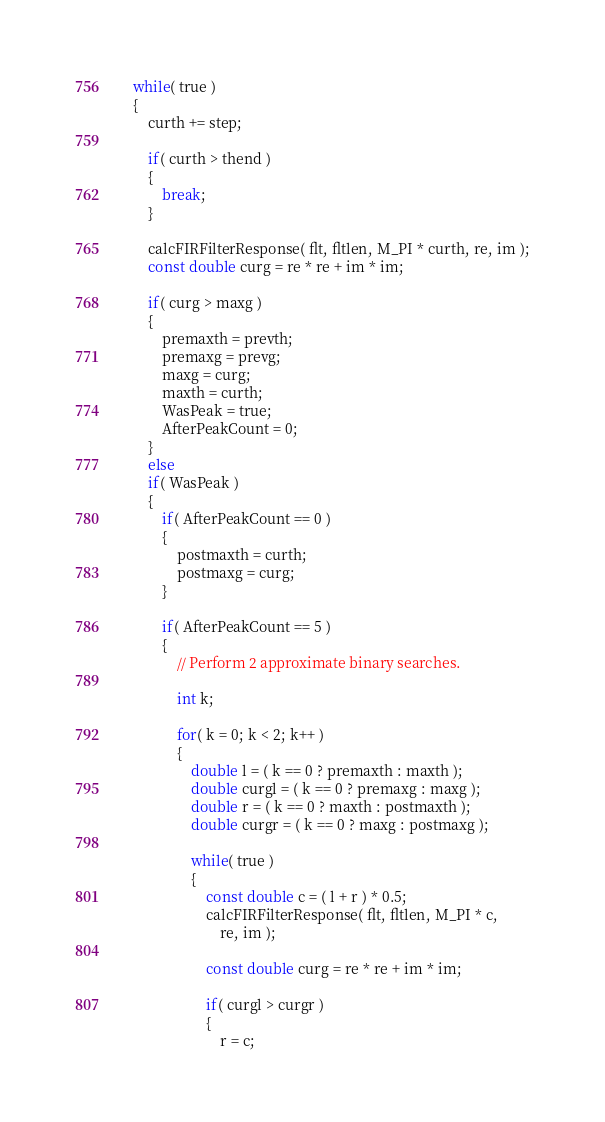<code> <loc_0><loc_0><loc_500><loc_500><_C_>
	while( true )
	{
		curth += step;

		if( curth > thend )
		{
			break;
		}

		calcFIRFilterResponse( flt, fltlen, M_PI * curth, re, im );
		const double curg = re * re + im * im;

		if( curg > maxg )
		{
			premaxth = prevth;
			premaxg = prevg;
			maxg = curg;
			maxth = curth;
			WasPeak = true;
			AfterPeakCount = 0;
		}
		else
		if( WasPeak )
		{
			if( AfterPeakCount == 0 )
			{
				postmaxth = curth;
				postmaxg = curg;
			}

			if( AfterPeakCount == 5 )
			{
				// Perform 2 approximate binary searches.

				int k;

				for( k = 0; k < 2; k++ )
				{
					double l = ( k == 0 ? premaxth : maxth );
					double curgl = ( k == 0 ? premaxg : maxg );
					double r = ( k == 0 ? maxth : postmaxth );
					double curgr = ( k == 0 ? maxg : postmaxg );

					while( true )
					{
						const double c = ( l + r ) * 0.5;
						calcFIRFilterResponse( flt, fltlen, M_PI * c,
							re, im );

						const double curg = re * re + im * im;

						if( curgl > curgr )
						{
							r = c;</code> 